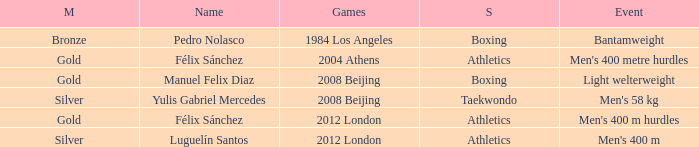Which Sport had an Event of men's 400 m hurdles? Athletics. 